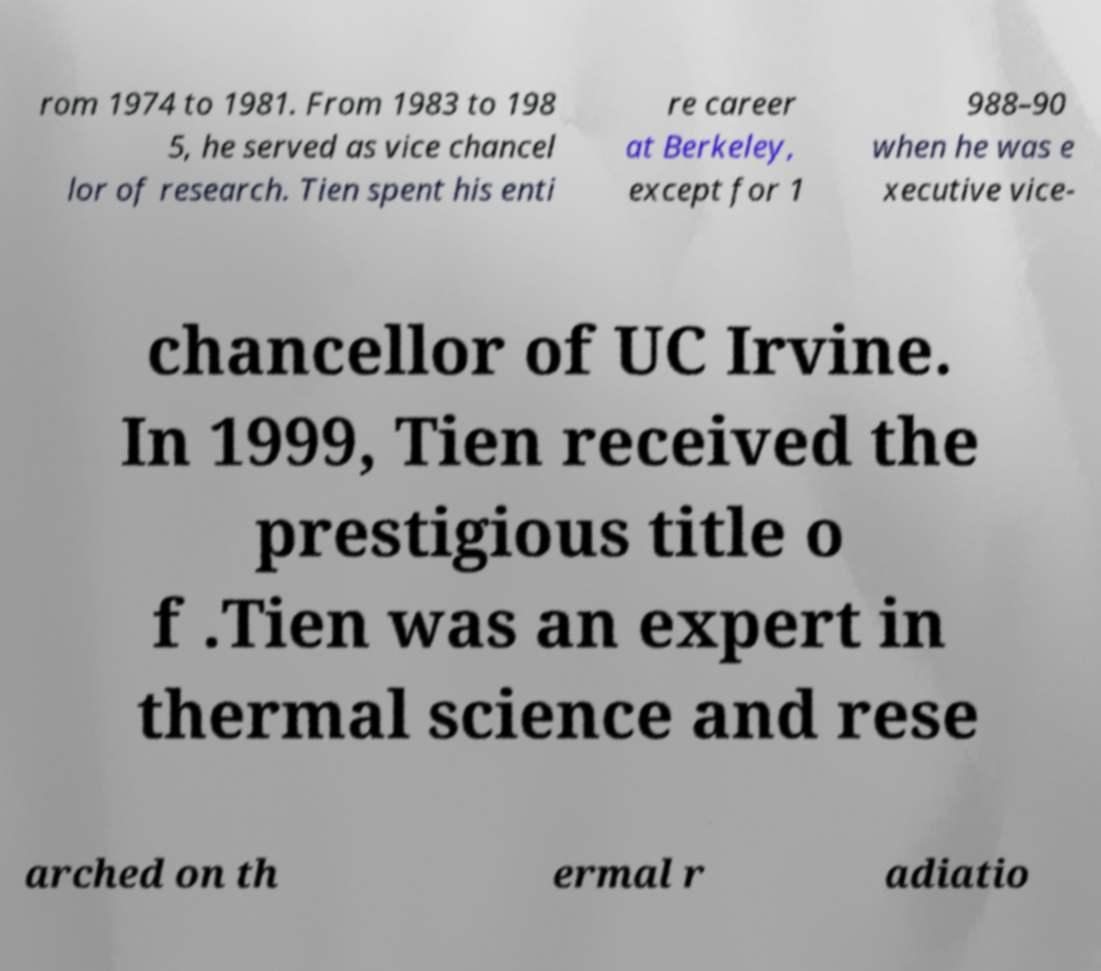There's text embedded in this image that I need extracted. Can you transcribe it verbatim? rom 1974 to 1981. From 1983 to 198 5, he served as vice chancel lor of research. Tien spent his enti re career at Berkeley, except for 1 988–90 when he was e xecutive vice- chancellor of UC Irvine. In 1999, Tien received the prestigious title o f .Tien was an expert in thermal science and rese arched on th ermal r adiatio 